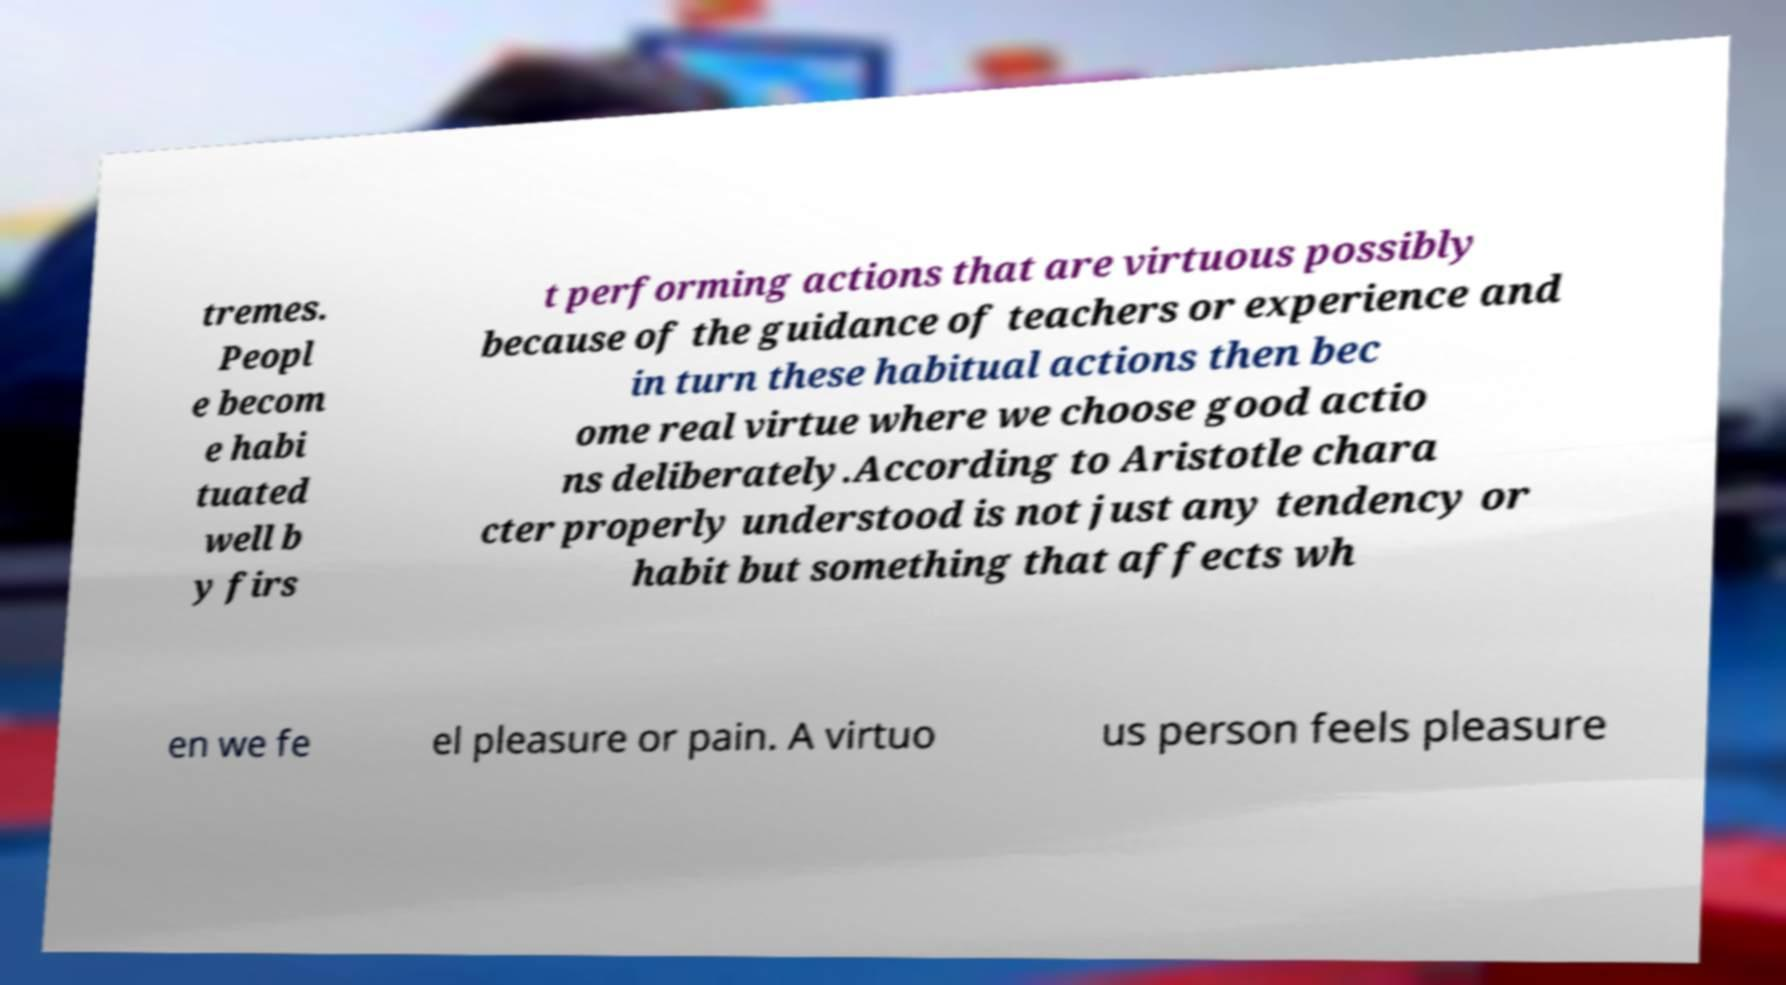Could you assist in decoding the text presented in this image and type it out clearly? tremes. Peopl e becom e habi tuated well b y firs t performing actions that are virtuous possibly because of the guidance of teachers or experience and in turn these habitual actions then bec ome real virtue where we choose good actio ns deliberately.According to Aristotle chara cter properly understood is not just any tendency or habit but something that affects wh en we fe el pleasure or pain. A virtuo us person feels pleasure 